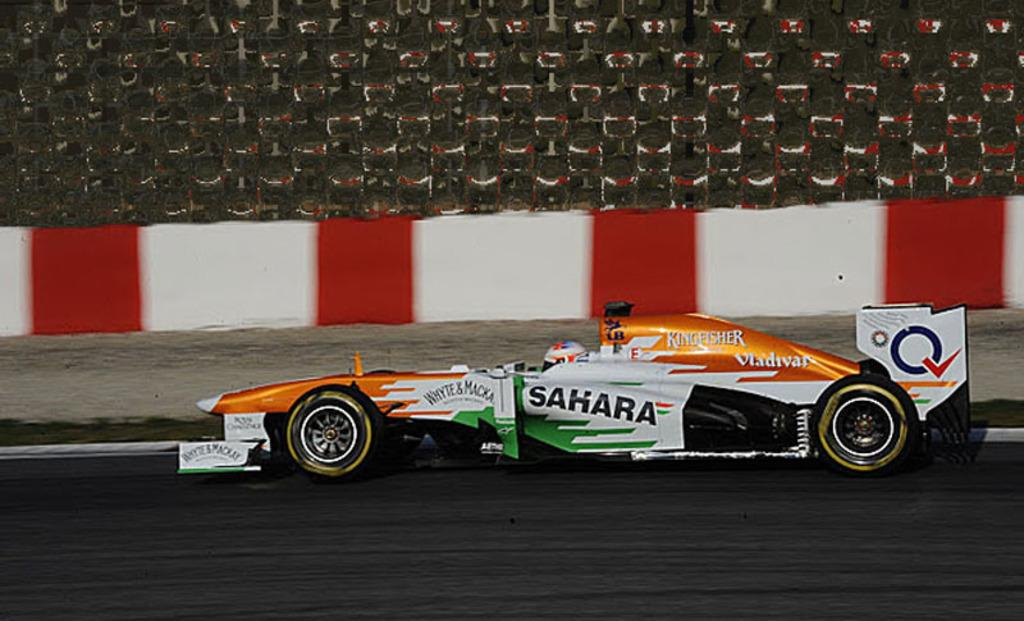What type of vehicle can be seen on the road in the image? There is a sports car visible on the road in the image. What structure is located in the middle of the image? There is a fence in the middle of the image. What type of structure is visible at the top of the image? There is a wall visible at the top of the image. What organization is responsible for maintaining the wheel in the image? There is no wheel present in the image, so it is not possible to determine which organization might be responsible for maintaining it. 